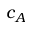Convert formula to latex. <formula><loc_0><loc_0><loc_500><loc_500>c _ { A }</formula> 